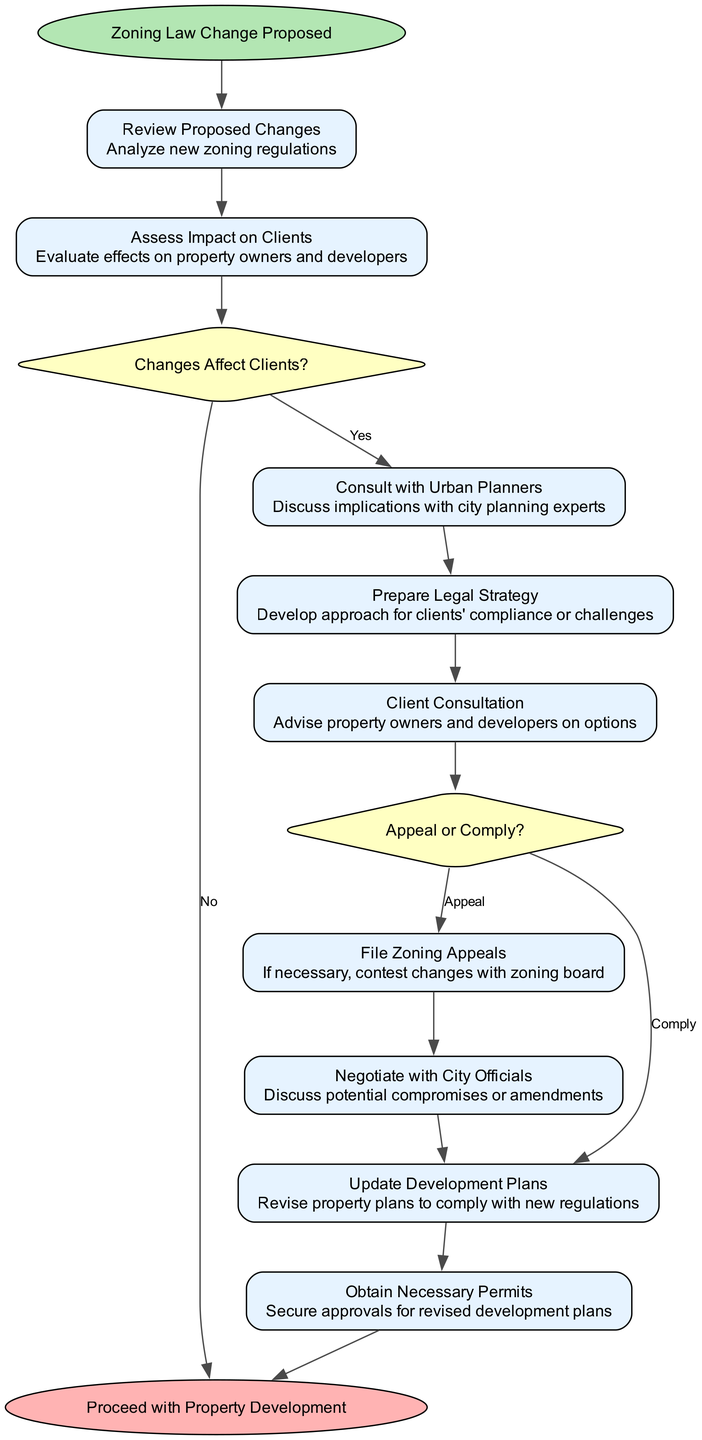What is the starting point of the clinical pathway? The clinical pathway begins with the node labeled "Zoning Law Change Proposed." This is directly indicated as the starting point in the diagram.
Answer: Zoning Law Change Proposed What is the final step of the clinical pathway? The last step in the pathway is marked as "Proceed with Property Development," which is the endpoint of the diagram.
Answer: Proceed with Property Development How many steps are there in total? There are 9 steps listed in the pathway, each representing a specific action taken in response to zoning law changes.
Answer: 9 What decision does the pathway lead to regarding whether changes affect clients? The flow leads to a decision point labeled "Changes Affect Clients?" which asks if the proposed changes have an impact.
Answer: Changes Affect Clients? What do clients do if they choose to appeal? If clients decide to appeal, the pathway directs them to the step "File Zoning Appeals," which indicates the action taken following the appeal decision.
Answer: File Zoning Appeals What is the relationship between "Client Consultation" and "Prepare Legal Strategy"? The flow shows that after "Prepare Legal Strategy," the next step is "Client Consultation," which implies that legal strategies are discussed with clients after being prepared.
Answer: Client Consultation follows Prepare Legal Strategy What happens after updating development plans? Following the step "Update Development Plans," the next required action is "Obtain Necessary Permits," indicating that permits are secured after plans are updated.
Answer: Obtain Necessary Permits What does the decision point "Appeal or Comply?" lead to if the choice is to comply? If the choice is to comply, the diagram guides to "Update Development Plans," indicating that compliance leads to revising plans.
Answer: Update Development Plans Which step occurs after consulting with urban planners? After the step "Consult with Urban Planners," the next action in the pathway is "Prepare Legal Strategy," showing the continuation of the process.
Answer: Prepare Legal Strategy 